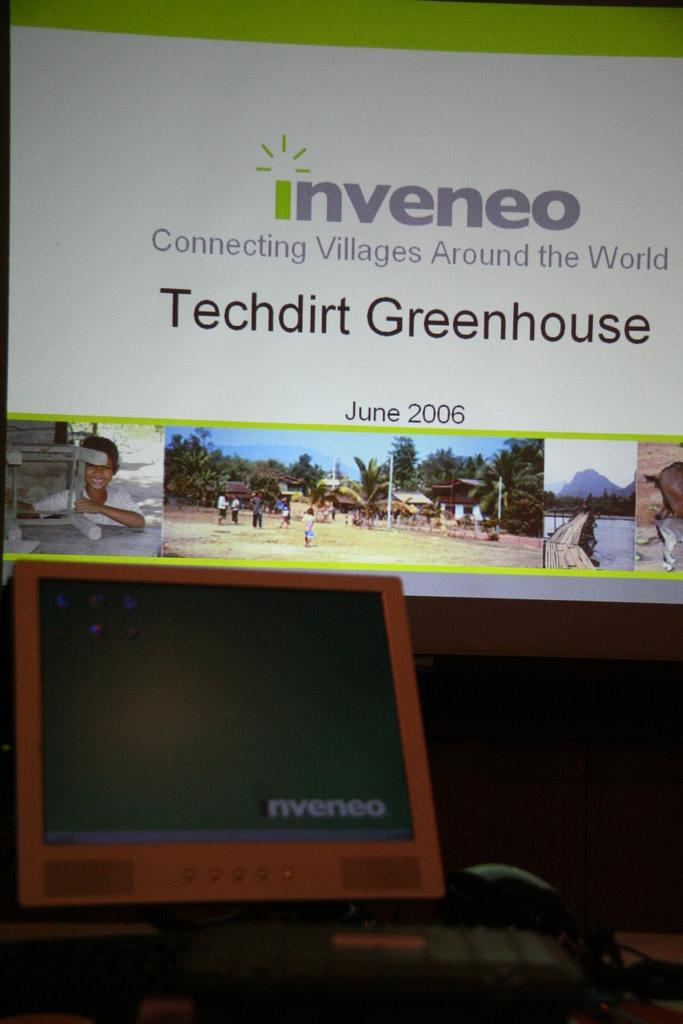Provide a one-sentence caption for the provided image. A sign from the company inveneo talking about a greenhouse. 